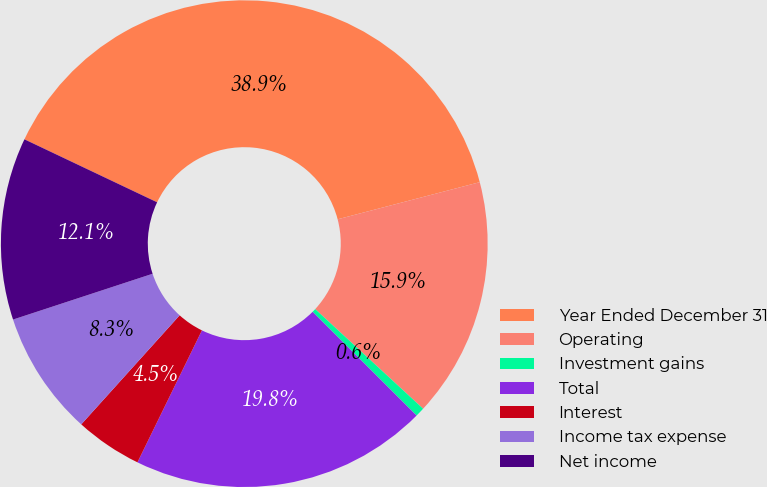Convert chart to OTSL. <chart><loc_0><loc_0><loc_500><loc_500><pie_chart><fcel>Year Ended December 31<fcel>Operating<fcel>Investment gains<fcel>Total<fcel>Interest<fcel>Income tax expense<fcel>Net income<nl><fcel>38.88%<fcel>15.93%<fcel>0.62%<fcel>19.75%<fcel>4.45%<fcel>8.27%<fcel>12.1%<nl></chart> 